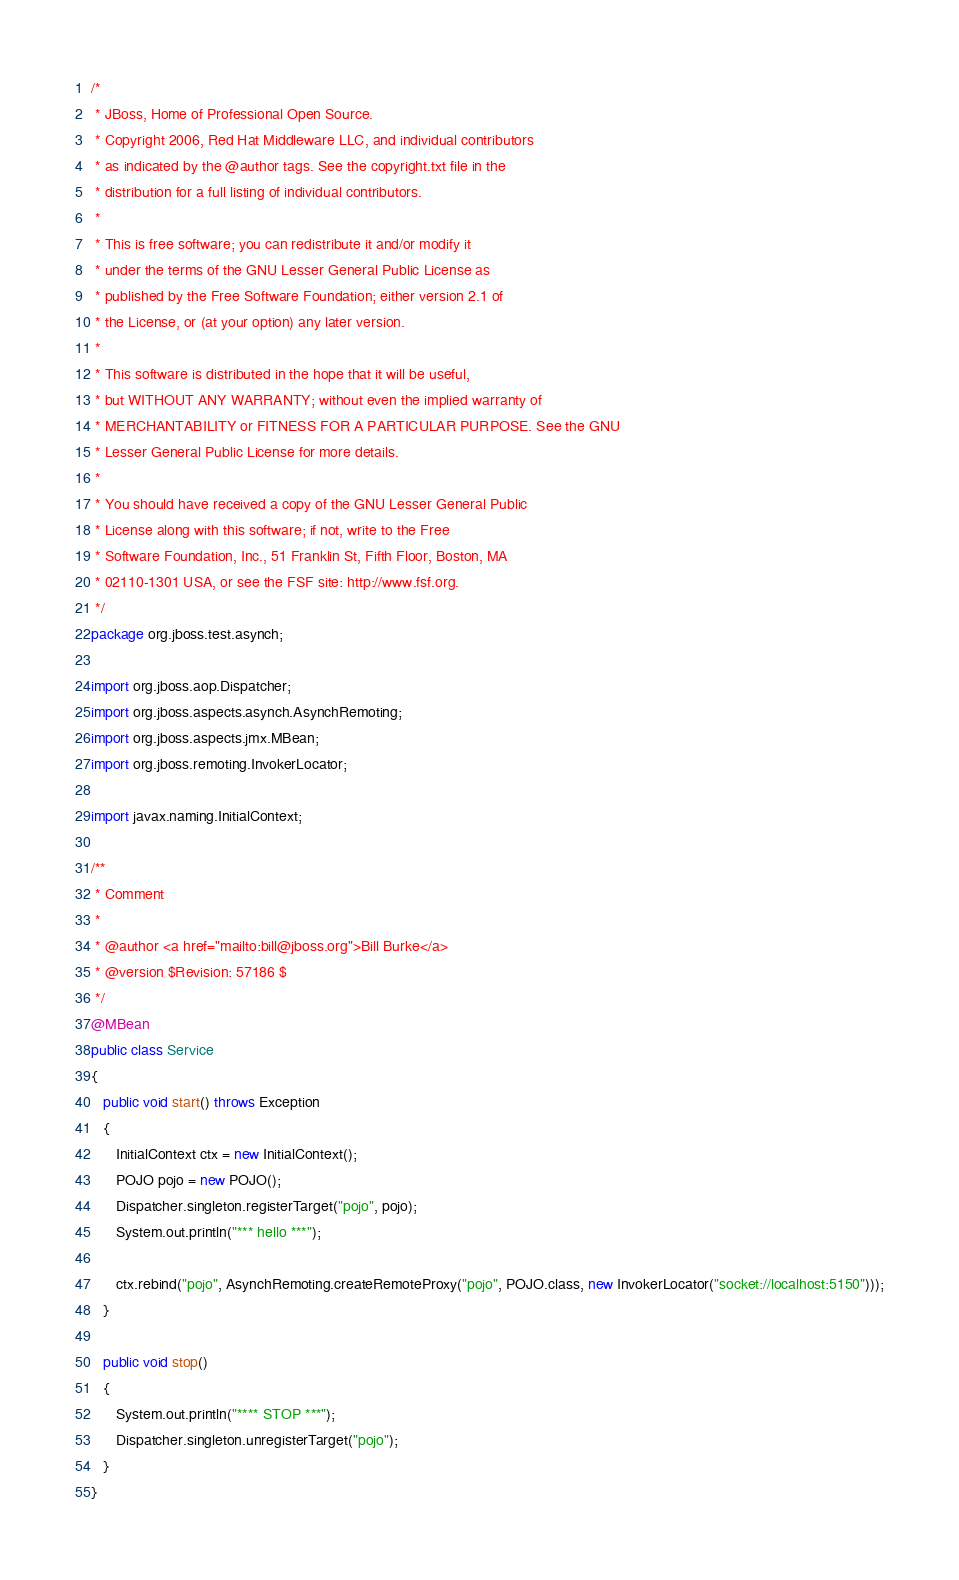Convert code to text. <code><loc_0><loc_0><loc_500><loc_500><_Java_>/*
 * JBoss, Home of Professional Open Source.
 * Copyright 2006, Red Hat Middleware LLC, and individual contributors
 * as indicated by the @author tags. See the copyright.txt file in the
 * distribution for a full listing of individual contributors.
 *
 * This is free software; you can redistribute it and/or modify it
 * under the terms of the GNU Lesser General Public License as
 * published by the Free Software Foundation; either version 2.1 of
 * the License, or (at your option) any later version.
 *
 * This software is distributed in the hope that it will be useful,
 * but WITHOUT ANY WARRANTY; without even the implied warranty of
 * MERCHANTABILITY or FITNESS FOR A PARTICULAR PURPOSE. See the GNU
 * Lesser General Public License for more details.
 *
 * You should have received a copy of the GNU Lesser General Public
 * License along with this software; if not, write to the Free
 * Software Foundation, Inc., 51 Franklin St, Fifth Floor, Boston, MA
 * 02110-1301 USA, or see the FSF site: http://www.fsf.org.
 */
package org.jboss.test.asynch;

import org.jboss.aop.Dispatcher;
import org.jboss.aspects.asynch.AsynchRemoting;
import org.jboss.aspects.jmx.MBean;
import org.jboss.remoting.InvokerLocator;

import javax.naming.InitialContext;

/**
 * Comment
 *
 * @author <a href="mailto:bill@jboss.org">Bill Burke</a>
 * @version $Revision: 57186 $
 */
@MBean
public class Service
{
   public void start() throws Exception
   {
      InitialContext ctx = new InitialContext();
      POJO pojo = new POJO();
      Dispatcher.singleton.registerTarget("pojo", pojo);
      System.out.println("*** hello ***");

      ctx.rebind("pojo", AsynchRemoting.createRemoteProxy("pojo", POJO.class, new InvokerLocator("socket://localhost:5150")));
   }

   public void stop()
   {
      System.out.println("**** STOP ***");
      Dispatcher.singleton.unregisterTarget("pojo");
   }
}
</code> 